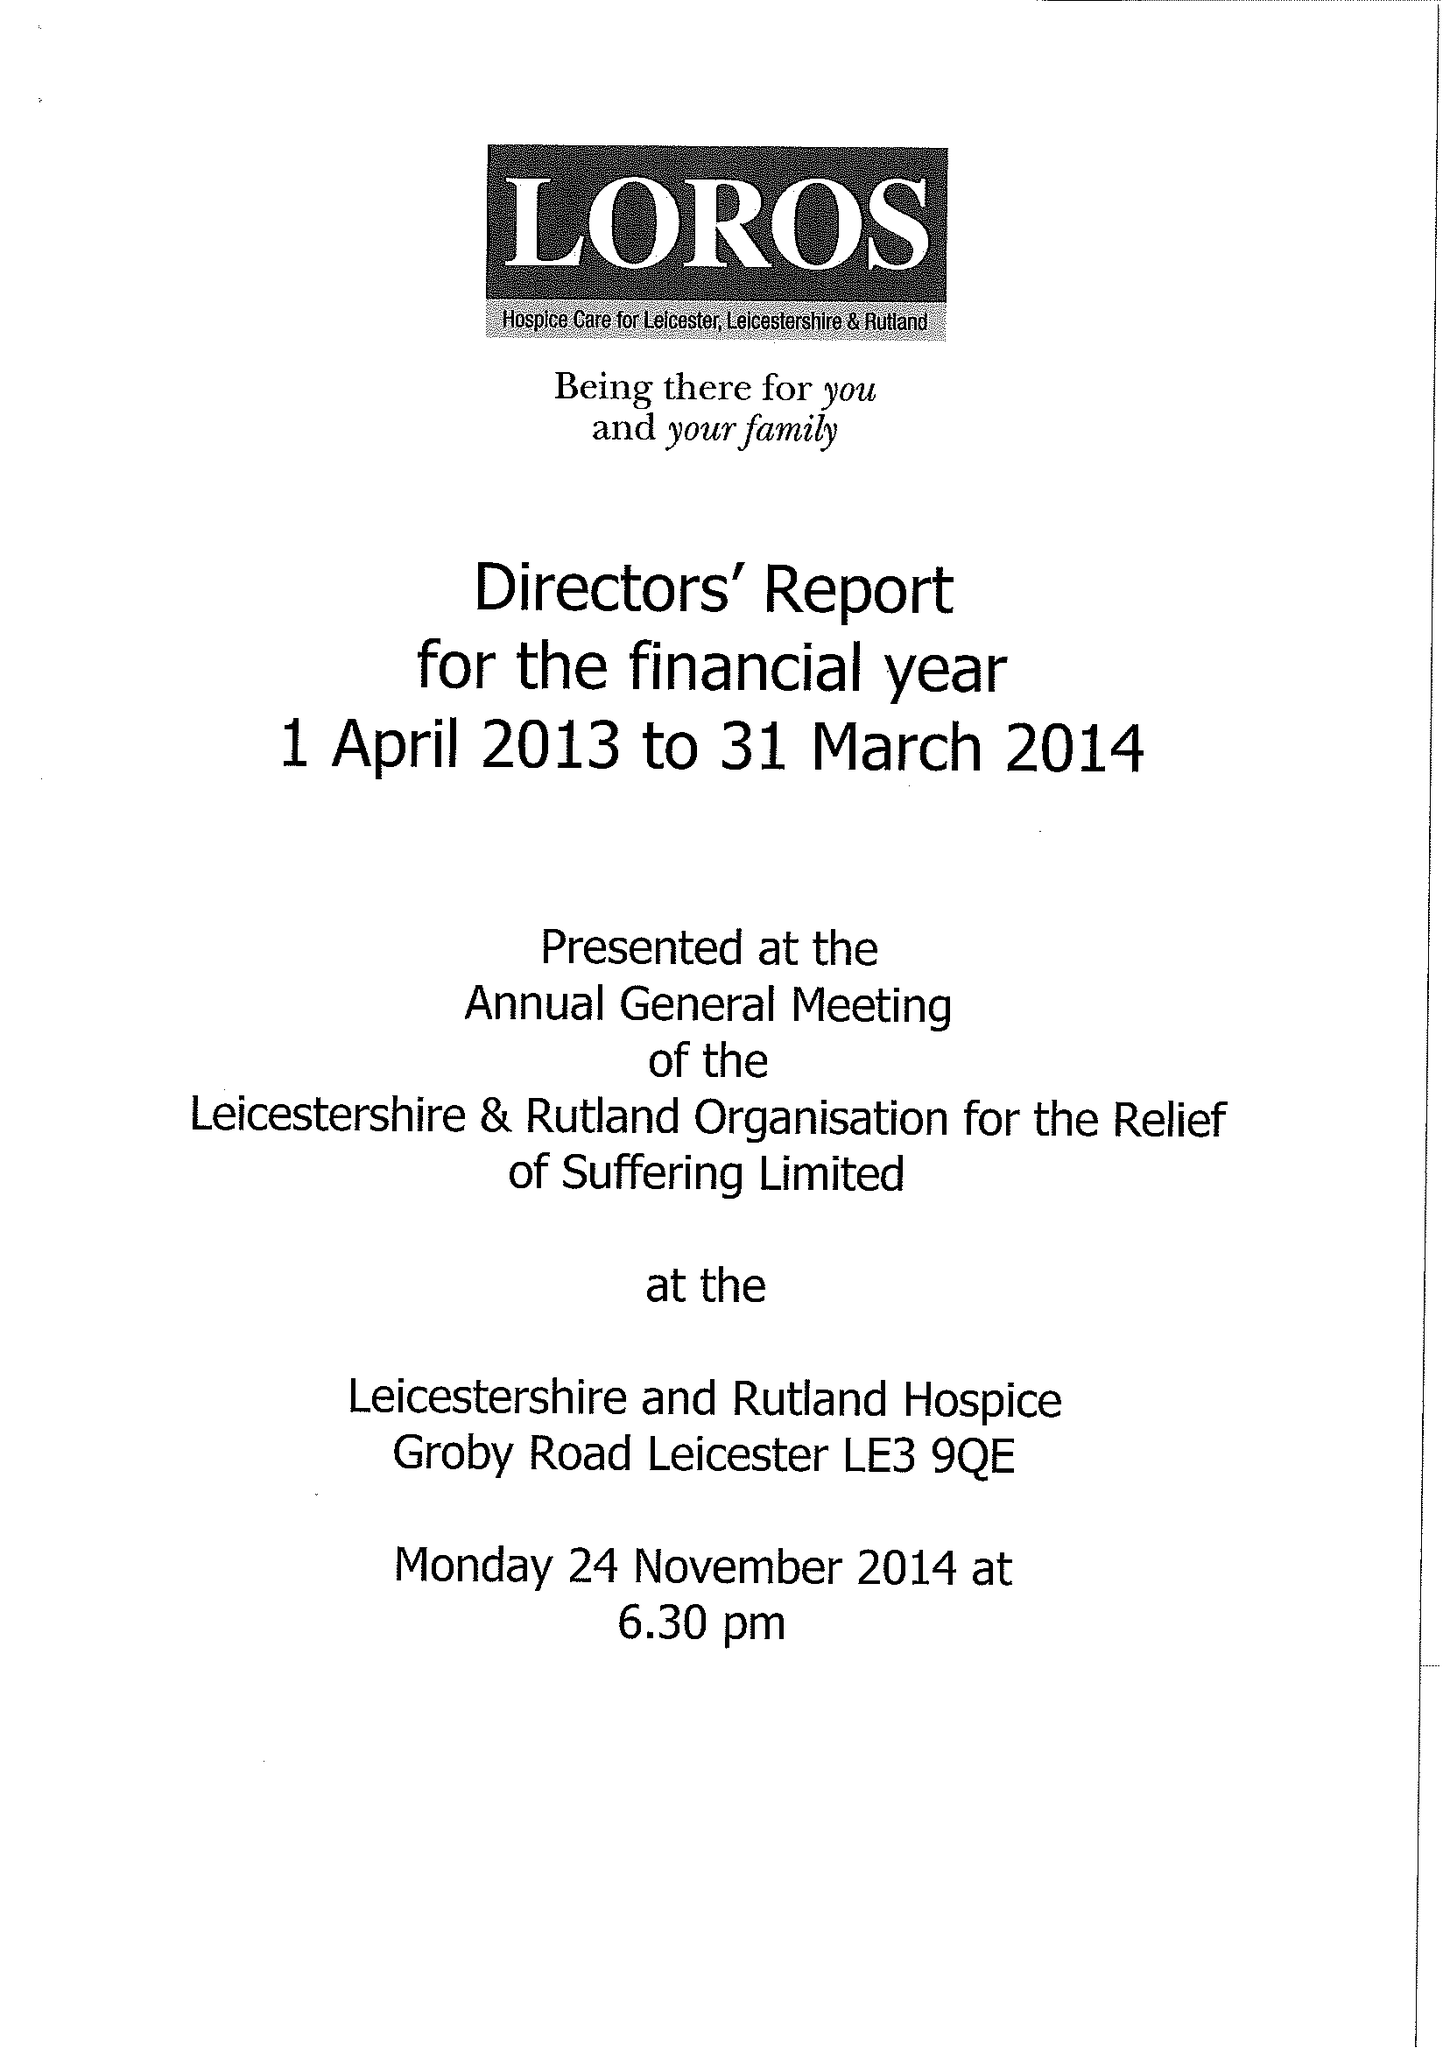What is the value for the address__post_town?
Answer the question using a single word or phrase. LEICESTER 